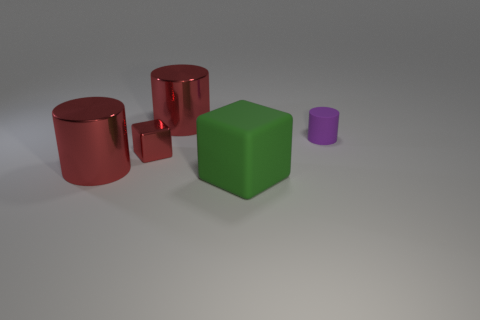How many objects have the same size as the green rubber block?
Provide a short and direct response. 2. There is a large shiny thing behind the large red thing to the left of the block behind the large matte thing; what is its shape?
Offer a terse response. Cylinder. What color is the object that is to the right of the large green object?
Offer a terse response. Purple. What number of objects are small things on the right side of the large green rubber block or matte objects that are behind the large green block?
Provide a short and direct response. 1. What number of other tiny purple objects have the same shape as the tiny metal object?
Provide a succinct answer. 0. What color is the rubber object that is the same size as the red metallic block?
Your answer should be compact. Purple. There is a large shiny cylinder that is in front of the big metallic cylinder that is behind the tiny thing right of the green matte object; what is its color?
Offer a terse response. Red. Do the purple thing and the shiny cylinder in front of the red shiny block have the same size?
Ensure brevity in your answer.  No. How many things are either red shiny cubes or large shiny objects?
Your response must be concise. 3. Are there any large red cubes made of the same material as the purple cylinder?
Offer a very short reply. No. 